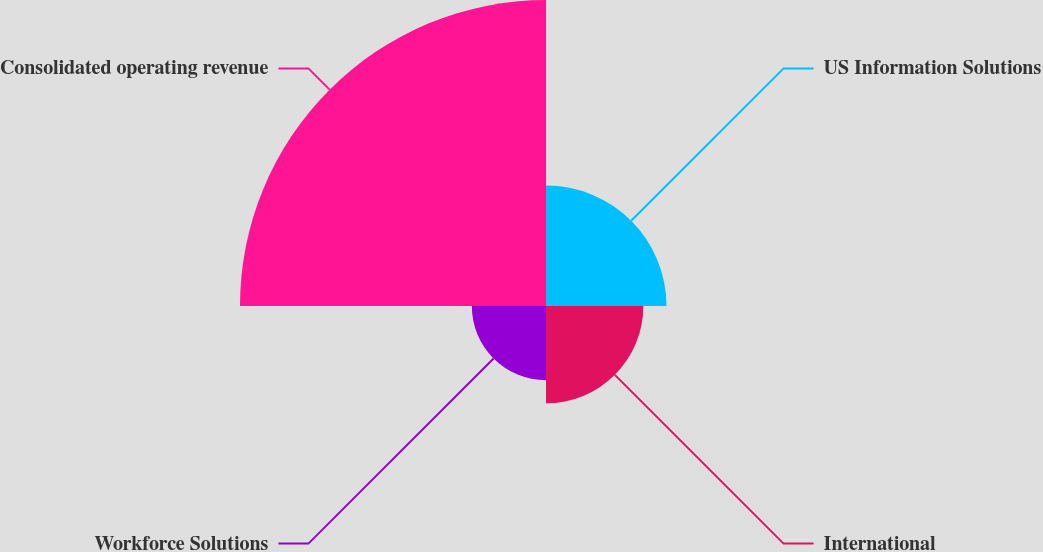<chart> <loc_0><loc_0><loc_500><loc_500><pie_chart><fcel>US Information Solutions<fcel>International<fcel>Workforce Solutions<fcel>Consolidated operating revenue<nl><fcel>20.15%<fcel>16.28%<fcel>12.4%<fcel>51.17%<nl></chart> 